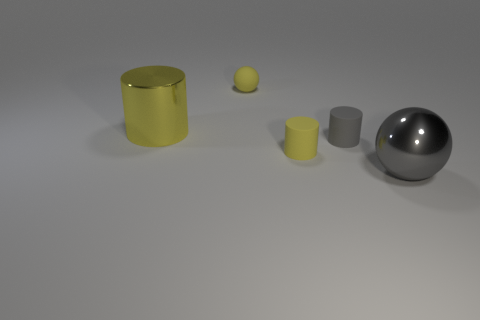Subtract all large cylinders. How many cylinders are left? 2 Add 1 tiny balls. How many objects exist? 6 Subtract all cylinders. How many objects are left? 2 Subtract 1 spheres. How many spheres are left? 1 Subtract all yellow cylinders. How many cylinders are left? 1 Subtract all small rubber spheres. Subtract all small cylinders. How many objects are left? 2 Add 3 big objects. How many big objects are left? 5 Add 5 small gray metal things. How many small gray metal things exist? 5 Subtract 0 purple cubes. How many objects are left? 5 Subtract all gray cylinders. Subtract all blue cubes. How many cylinders are left? 2 